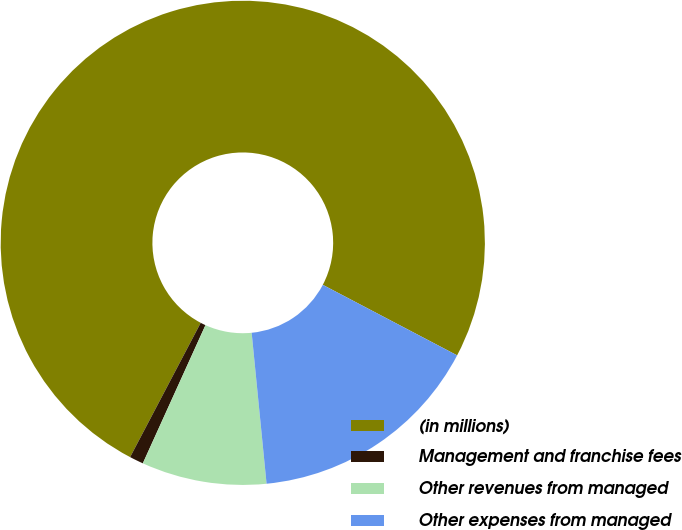Convert chart. <chart><loc_0><loc_0><loc_500><loc_500><pie_chart><fcel>(in millions)<fcel>Management and franchise fees<fcel>Other revenues from managed<fcel>Other expenses from managed<nl><fcel>74.99%<fcel>0.93%<fcel>8.34%<fcel>15.74%<nl></chart> 